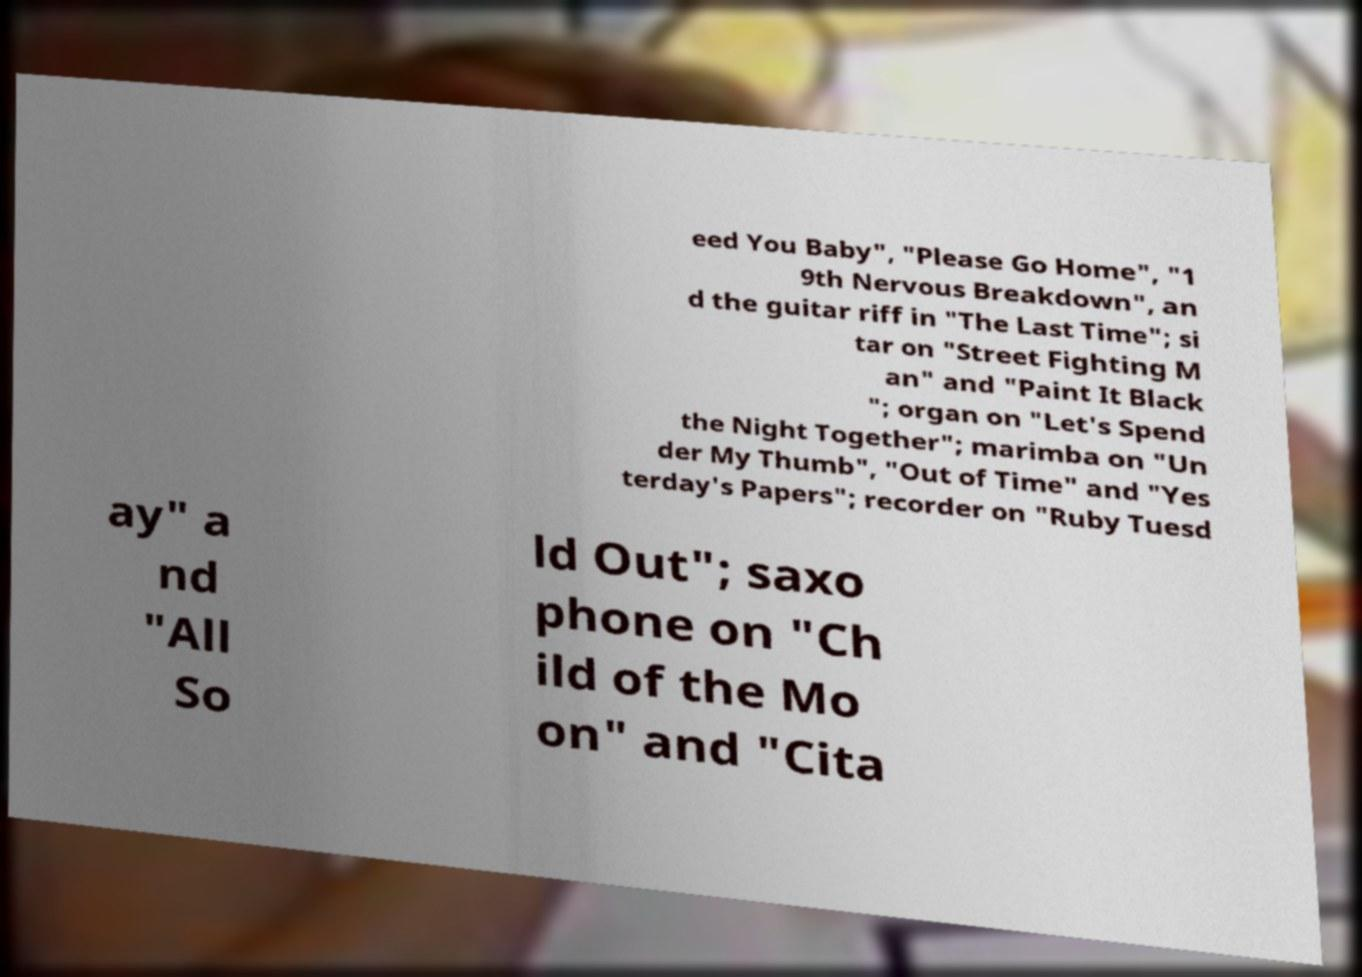What messages or text are displayed in this image? I need them in a readable, typed format. eed You Baby", "Please Go Home", "1 9th Nervous Breakdown", an d the guitar riff in "The Last Time"; si tar on "Street Fighting M an" and "Paint It Black "; organ on "Let's Spend the Night Together"; marimba on "Un der My Thumb", "Out of Time" and "Yes terday's Papers"; recorder on "Ruby Tuesd ay" a nd "All So ld Out"; saxo phone on "Ch ild of the Mo on" and "Cita 